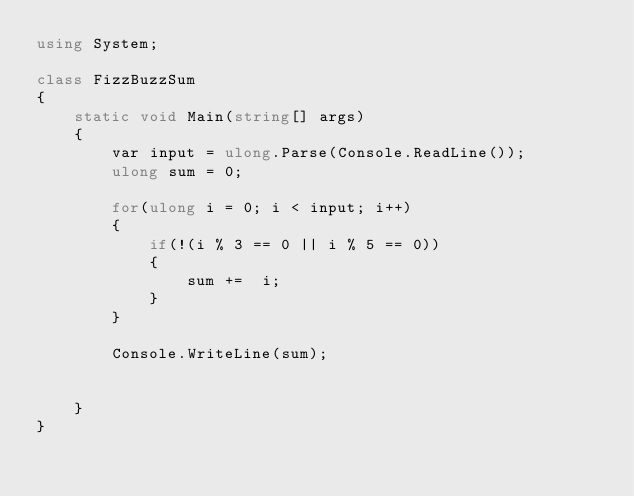<code> <loc_0><loc_0><loc_500><loc_500><_C#_>using System;

class FizzBuzzSum
{
    static void Main(string[] args)
    {
        var input = ulong.Parse(Console.ReadLine());
        ulong sum = 0;

        for(ulong i = 0; i < input; i++)
        {
            if(!(i % 3 == 0 || i % 5 == 0))
            {
                sum +=  i;
            }
        }

        Console.WriteLine(sum);

       
    }
}</code> 